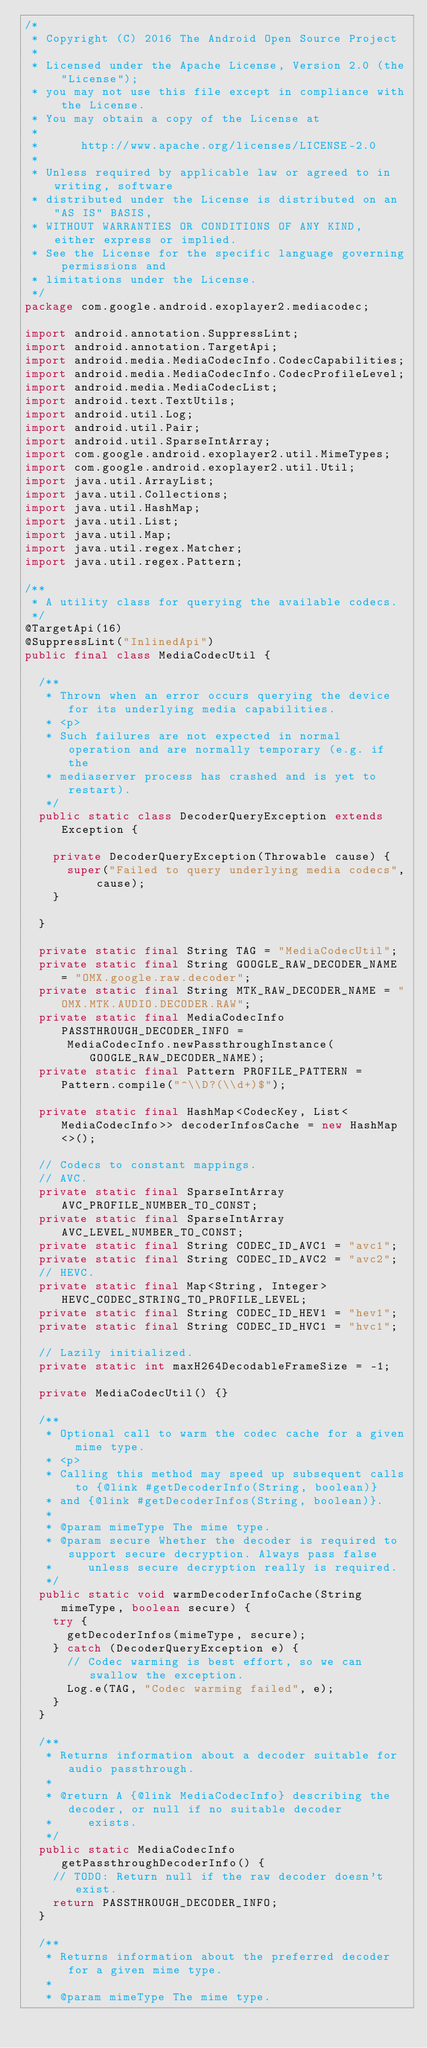Convert code to text. <code><loc_0><loc_0><loc_500><loc_500><_Java_>/*
 * Copyright (C) 2016 The Android Open Source Project
 *
 * Licensed under the Apache License, Version 2.0 (the "License");
 * you may not use this file except in compliance with the License.
 * You may obtain a copy of the License at
 *
 *      http://www.apache.org/licenses/LICENSE-2.0
 *
 * Unless required by applicable law or agreed to in writing, software
 * distributed under the License is distributed on an "AS IS" BASIS,
 * WITHOUT WARRANTIES OR CONDITIONS OF ANY KIND, either express or implied.
 * See the License for the specific language governing permissions and
 * limitations under the License.
 */
package com.google.android.exoplayer2.mediacodec;

import android.annotation.SuppressLint;
import android.annotation.TargetApi;
import android.media.MediaCodecInfo.CodecCapabilities;
import android.media.MediaCodecInfo.CodecProfileLevel;
import android.media.MediaCodecList;
import android.text.TextUtils;
import android.util.Log;
import android.util.Pair;
import android.util.SparseIntArray;
import com.google.android.exoplayer2.util.MimeTypes;
import com.google.android.exoplayer2.util.Util;
import java.util.ArrayList;
import java.util.Collections;
import java.util.HashMap;
import java.util.List;
import java.util.Map;
import java.util.regex.Matcher;
import java.util.regex.Pattern;

/**
 * A utility class for querying the available codecs.
 */
@TargetApi(16)
@SuppressLint("InlinedApi")
public final class MediaCodecUtil {

  /**
   * Thrown when an error occurs querying the device for its underlying media capabilities.
   * <p>
   * Such failures are not expected in normal operation and are normally temporary (e.g. if the
   * mediaserver process has crashed and is yet to restart).
   */
  public static class DecoderQueryException extends Exception {

    private DecoderQueryException(Throwable cause) {
      super("Failed to query underlying media codecs", cause);
    }

  }

  private static final String TAG = "MediaCodecUtil";
  private static final String GOOGLE_RAW_DECODER_NAME = "OMX.google.raw.decoder";
  private static final String MTK_RAW_DECODER_NAME = "OMX.MTK.AUDIO.DECODER.RAW";
  private static final MediaCodecInfo PASSTHROUGH_DECODER_INFO =
      MediaCodecInfo.newPassthroughInstance(GOOGLE_RAW_DECODER_NAME);
  private static final Pattern PROFILE_PATTERN = Pattern.compile("^\\D?(\\d+)$");

  private static final HashMap<CodecKey, List<MediaCodecInfo>> decoderInfosCache = new HashMap<>();

  // Codecs to constant mappings.
  // AVC.
  private static final SparseIntArray AVC_PROFILE_NUMBER_TO_CONST;
  private static final SparseIntArray AVC_LEVEL_NUMBER_TO_CONST;
  private static final String CODEC_ID_AVC1 = "avc1";
  private static final String CODEC_ID_AVC2 = "avc2";
  // HEVC.
  private static final Map<String, Integer> HEVC_CODEC_STRING_TO_PROFILE_LEVEL;
  private static final String CODEC_ID_HEV1 = "hev1";
  private static final String CODEC_ID_HVC1 = "hvc1";

  // Lazily initialized.
  private static int maxH264DecodableFrameSize = -1;

  private MediaCodecUtil() {}

  /**
   * Optional call to warm the codec cache for a given mime type.
   * <p>
   * Calling this method may speed up subsequent calls to {@link #getDecoderInfo(String, boolean)}
   * and {@link #getDecoderInfos(String, boolean)}.
   *
   * @param mimeType The mime type.
   * @param secure Whether the decoder is required to support secure decryption. Always pass false
   *     unless secure decryption really is required.
   */
  public static void warmDecoderInfoCache(String mimeType, boolean secure) {
    try {
      getDecoderInfos(mimeType, secure);
    } catch (DecoderQueryException e) {
      // Codec warming is best effort, so we can swallow the exception.
      Log.e(TAG, "Codec warming failed", e);
    }
  }

  /**
   * Returns information about a decoder suitable for audio passthrough.
   *
   * @return A {@link MediaCodecInfo} describing the decoder, or null if no suitable decoder
   *     exists.
   */
  public static MediaCodecInfo getPassthroughDecoderInfo() {
    // TODO: Return null if the raw decoder doesn't exist.
    return PASSTHROUGH_DECODER_INFO;
  }

  /**
   * Returns information about the preferred decoder for a given mime type.
   *
   * @param mimeType The mime type.</code> 